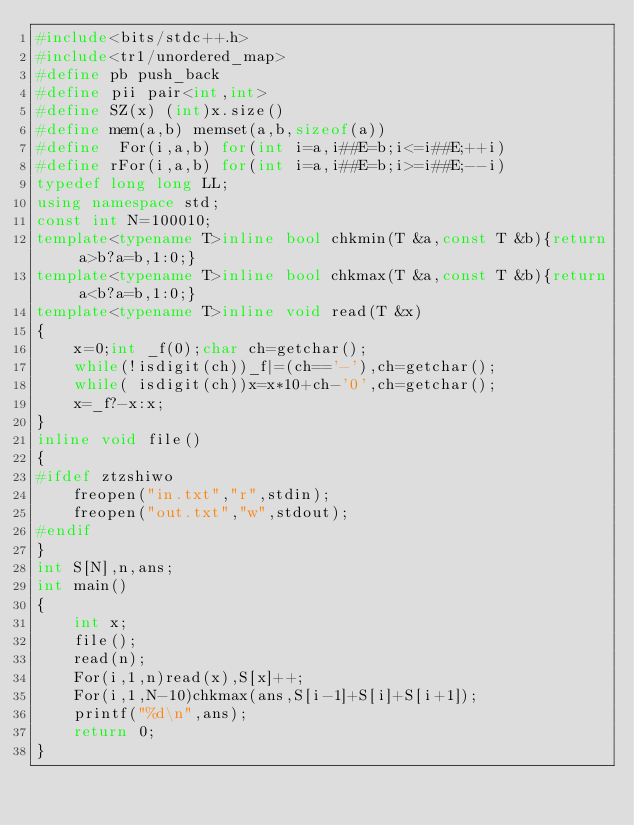Convert code to text. <code><loc_0><loc_0><loc_500><loc_500><_C++_>#include<bits/stdc++.h>
#include<tr1/unordered_map>
#define pb push_back
#define pii pair<int,int>
#define SZ(x) (int)x.size()
#define mem(a,b) memset(a,b,sizeof(a))
#define  For(i,a,b) for(int i=a,i##E=b;i<=i##E;++i)
#define rFor(i,a,b) for(int i=a,i##E=b;i>=i##E;--i)
typedef long long LL;
using namespace std;
const int N=100010;
template<typename T>inline bool chkmin(T &a,const T &b){return a>b?a=b,1:0;}
template<typename T>inline bool chkmax(T &a,const T &b){return a<b?a=b,1:0;}
template<typename T>inline void read(T &x)
{
	x=0;int _f(0);char ch=getchar();
	while(!isdigit(ch))_f|=(ch=='-'),ch=getchar();
	while( isdigit(ch))x=x*10+ch-'0',ch=getchar();
	x=_f?-x:x;
}
inline void file()
{
#ifdef ztzshiwo
	freopen("in.txt","r",stdin);
	freopen("out.txt","w",stdout);
#endif
}
int S[N],n,ans;
int main()
{
	int x;
	file();
	read(n);
	For(i,1,n)read(x),S[x]++;
	For(i,1,N-10)chkmax(ans,S[i-1]+S[i]+S[i+1]);
	printf("%d\n",ans);
	return 0;
}
</code> 